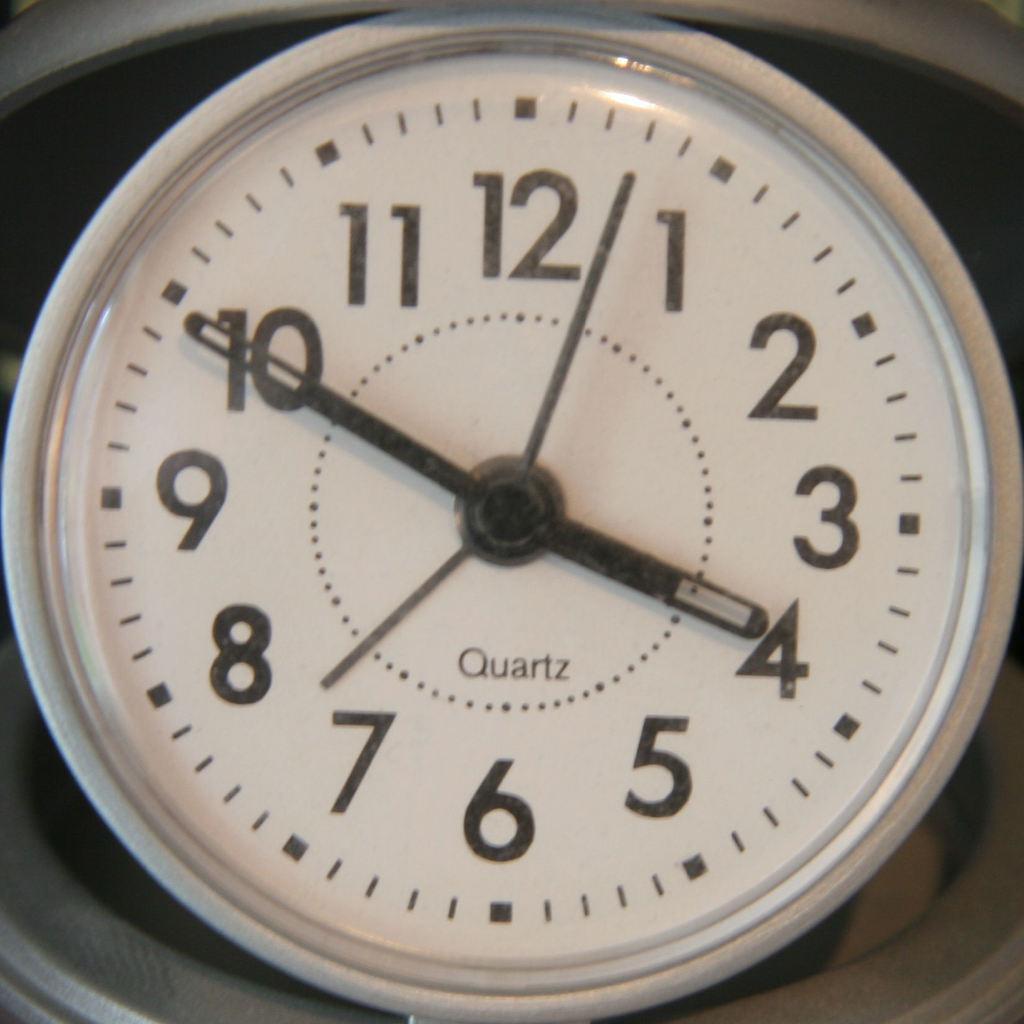<image>
Offer a succinct explanation of the picture presented. The time is currently 3:50 on this clock. 